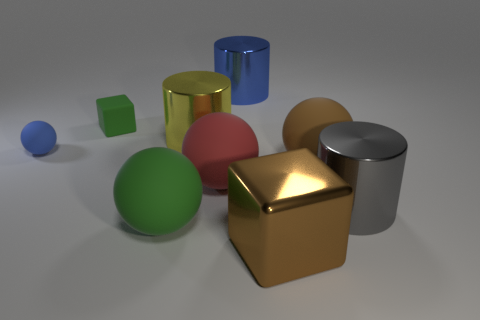Imagine these objects are part of a child's play area. Can you create a story of how they might use them? In a child's imaginative play area, these objects could be integral to an adventurous tale. The shiny gold cube, with its lustrous surface, might be the treasure that a young adventurer has been seeking. The blue and red spheres could represent planets in a vast galaxy, the green cube could be a magical building block that constructs anything the child imagines, and the silver cylinder might be a rocket that transports them between these planetary spheres. The large brown sphere could be the 'world' where all these fantastical events converge. Together, with a healthy dose of creativity, these objects become key elements in the child's journey through space and time in their playtime saga. 